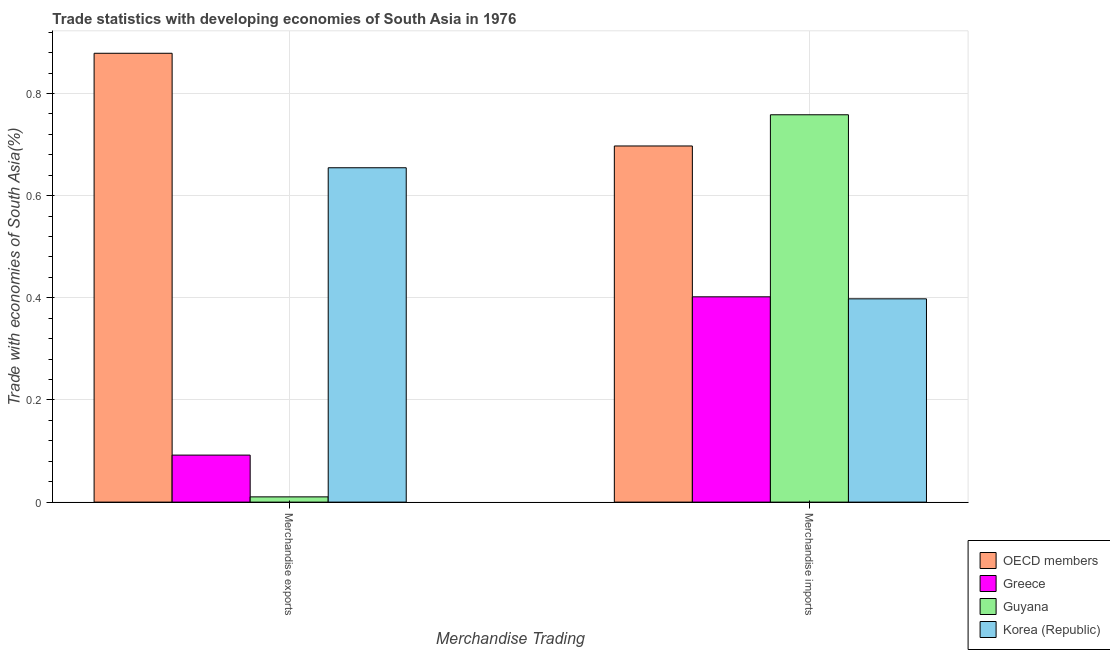How many different coloured bars are there?
Give a very brief answer. 4. Are the number of bars per tick equal to the number of legend labels?
Keep it short and to the point. Yes. Are the number of bars on each tick of the X-axis equal?
Offer a terse response. Yes. How many bars are there on the 1st tick from the left?
Your answer should be very brief. 4. What is the label of the 1st group of bars from the left?
Provide a succinct answer. Merchandise exports. What is the merchandise imports in Greece?
Your response must be concise. 0.4. Across all countries, what is the maximum merchandise exports?
Give a very brief answer. 0.88. Across all countries, what is the minimum merchandise imports?
Offer a terse response. 0.4. In which country was the merchandise imports maximum?
Make the answer very short. Guyana. In which country was the merchandise imports minimum?
Provide a succinct answer. Korea (Republic). What is the total merchandise imports in the graph?
Your response must be concise. 2.26. What is the difference between the merchandise imports in Korea (Republic) and that in Greece?
Your answer should be very brief. -0. What is the difference between the merchandise imports in Guyana and the merchandise exports in OECD members?
Your response must be concise. -0.12. What is the average merchandise imports per country?
Make the answer very short. 0.56. What is the difference between the merchandise exports and merchandise imports in Guyana?
Make the answer very short. -0.75. In how many countries, is the merchandise exports greater than 0.52 %?
Make the answer very short. 2. What is the ratio of the merchandise exports in OECD members to that in Greece?
Your answer should be compact. 9.55. Is the merchandise exports in Greece less than that in Guyana?
Your response must be concise. No. In how many countries, is the merchandise imports greater than the average merchandise imports taken over all countries?
Offer a very short reply. 2. What does the 3rd bar from the left in Merchandise exports represents?
Your answer should be compact. Guyana. Are all the bars in the graph horizontal?
Provide a short and direct response. No. Are the values on the major ticks of Y-axis written in scientific E-notation?
Offer a terse response. No. What is the title of the graph?
Your response must be concise. Trade statistics with developing economies of South Asia in 1976. What is the label or title of the X-axis?
Offer a very short reply. Merchandise Trading. What is the label or title of the Y-axis?
Your answer should be very brief. Trade with economies of South Asia(%). What is the Trade with economies of South Asia(%) of OECD members in Merchandise exports?
Give a very brief answer. 0.88. What is the Trade with economies of South Asia(%) in Greece in Merchandise exports?
Keep it short and to the point. 0.09. What is the Trade with economies of South Asia(%) of Guyana in Merchandise exports?
Your response must be concise. 0.01. What is the Trade with economies of South Asia(%) in Korea (Republic) in Merchandise exports?
Make the answer very short. 0.65. What is the Trade with economies of South Asia(%) in OECD members in Merchandise imports?
Offer a very short reply. 0.7. What is the Trade with economies of South Asia(%) of Greece in Merchandise imports?
Offer a terse response. 0.4. What is the Trade with economies of South Asia(%) of Guyana in Merchandise imports?
Your response must be concise. 0.76. What is the Trade with economies of South Asia(%) in Korea (Republic) in Merchandise imports?
Offer a very short reply. 0.4. Across all Merchandise Trading, what is the maximum Trade with economies of South Asia(%) in OECD members?
Offer a terse response. 0.88. Across all Merchandise Trading, what is the maximum Trade with economies of South Asia(%) in Greece?
Your response must be concise. 0.4. Across all Merchandise Trading, what is the maximum Trade with economies of South Asia(%) in Guyana?
Your response must be concise. 0.76. Across all Merchandise Trading, what is the maximum Trade with economies of South Asia(%) of Korea (Republic)?
Offer a very short reply. 0.65. Across all Merchandise Trading, what is the minimum Trade with economies of South Asia(%) in OECD members?
Offer a very short reply. 0.7. Across all Merchandise Trading, what is the minimum Trade with economies of South Asia(%) in Greece?
Your answer should be compact. 0.09. Across all Merchandise Trading, what is the minimum Trade with economies of South Asia(%) of Guyana?
Keep it short and to the point. 0.01. Across all Merchandise Trading, what is the minimum Trade with economies of South Asia(%) of Korea (Republic)?
Your answer should be compact. 0.4. What is the total Trade with economies of South Asia(%) of OECD members in the graph?
Keep it short and to the point. 1.58. What is the total Trade with economies of South Asia(%) in Greece in the graph?
Provide a short and direct response. 0.49. What is the total Trade with economies of South Asia(%) of Guyana in the graph?
Keep it short and to the point. 0.77. What is the total Trade with economies of South Asia(%) of Korea (Republic) in the graph?
Provide a succinct answer. 1.05. What is the difference between the Trade with economies of South Asia(%) in OECD members in Merchandise exports and that in Merchandise imports?
Ensure brevity in your answer.  0.18. What is the difference between the Trade with economies of South Asia(%) of Greece in Merchandise exports and that in Merchandise imports?
Your response must be concise. -0.31. What is the difference between the Trade with economies of South Asia(%) of Guyana in Merchandise exports and that in Merchandise imports?
Offer a terse response. -0.75. What is the difference between the Trade with economies of South Asia(%) of Korea (Republic) in Merchandise exports and that in Merchandise imports?
Give a very brief answer. 0.26. What is the difference between the Trade with economies of South Asia(%) of OECD members in Merchandise exports and the Trade with economies of South Asia(%) of Greece in Merchandise imports?
Offer a very short reply. 0.48. What is the difference between the Trade with economies of South Asia(%) in OECD members in Merchandise exports and the Trade with economies of South Asia(%) in Guyana in Merchandise imports?
Make the answer very short. 0.12. What is the difference between the Trade with economies of South Asia(%) of OECD members in Merchandise exports and the Trade with economies of South Asia(%) of Korea (Republic) in Merchandise imports?
Your response must be concise. 0.48. What is the difference between the Trade with economies of South Asia(%) of Greece in Merchandise exports and the Trade with economies of South Asia(%) of Guyana in Merchandise imports?
Offer a very short reply. -0.67. What is the difference between the Trade with economies of South Asia(%) in Greece in Merchandise exports and the Trade with economies of South Asia(%) in Korea (Republic) in Merchandise imports?
Your answer should be very brief. -0.31. What is the difference between the Trade with economies of South Asia(%) of Guyana in Merchandise exports and the Trade with economies of South Asia(%) of Korea (Republic) in Merchandise imports?
Ensure brevity in your answer.  -0.39. What is the average Trade with economies of South Asia(%) in OECD members per Merchandise Trading?
Give a very brief answer. 0.79. What is the average Trade with economies of South Asia(%) of Greece per Merchandise Trading?
Provide a succinct answer. 0.25. What is the average Trade with economies of South Asia(%) of Guyana per Merchandise Trading?
Give a very brief answer. 0.38. What is the average Trade with economies of South Asia(%) of Korea (Republic) per Merchandise Trading?
Provide a short and direct response. 0.53. What is the difference between the Trade with economies of South Asia(%) of OECD members and Trade with economies of South Asia(%) of Greece in Merchandise exports?
Provide a short and direct response. 0.79. What is the difference between the Trade with economies of South Asia(%) in OECD members and Trade with economies of South Asia(%) in Guyana in Merchandise exports?
Make the answer very short. 0.87. What is the difference between the Trade with economies of South Asia(%) in OECD members and Trade with economies of South Asia(%) in Korea (Republic) in Merchandise exports?
Give a very brief answer. 0.22. What is the difference between the Trade with economies of South Asia(%) in Greece and Trade with economies of South Asia(%) in Guyana in Merchandise exports?
Offer a terse response. 0.08. What is the difference between the Trade with economies of South Asia(%) in Greece and Trade with economies of South Asia(%) in Korea (Republic) in Merchandise exports?
Keep it short and to the point. -0.56. What is the difference between the Trade with economies of South Asia(%) in Guyana and Trade with economies of South Asia(%) in Korea (Republic) in Merchandise exports?
Your answer should be compact. -0.64. What is the difference between the Trade with economies of South Asia(%) in OECD members and Trade with economies of South Asia(%) in Greece in Merchandise imports?
Your answer should be compact. 0.3. What is the difference between the Trade with economies of South Asia(%) of OECD members and Trade with economies of South Asia(%) of Guyana in Merchandise imports?
Your answer should be compact. -0.06. What is the difference between the Trade with economies of South Asia(%) of OECD members and Trade with economies of South Asia(%) of Korea (Republic) in Merchandise imports?
Ensure brevity in your answer.  0.3. What is the difference between the Trade with economies of South Asia(%) in Greece and Trade with economies of South Asia(%) in Guyana in Merchandise imports?
Give a very brief answer. -0.36. What is the difference between the Trade with economies of South Asia(%) of Greece and Trade with economies of South Asia(%) of Korea (Republic) in Merchandise imports?
Offer a terse response. 0. What is the difference between the Trade with economies of South Asia(%) in Guyana and Trade with economies of South Asia(%) in Korea (Republic) in Merchandise imports?
Your response must be concise. 0.36. What is the ratio of the Trade with economies of South Asia(%) in OECD members in Merchandise exports to that in Merchandise imports?
Your response must be concise. 1.26. What is the ratio of the Trade with economies of South Asia(%) of Greece in Merchandise exports to that in Merchandise imports?
Your response must be concise. 0.23. What is the ratio of the Trade with economies of South Asia(%) in Guyana in Merchandise exports to that in Merchandise imports?
Your answer should be compact. 0.01. What is the ratio of the Trade with economies of South Asia(%) in Korea (Republic) in Merchandise exports to that in Merchandise imports?
Keep it short and to the point. 1.64. What is the difference between the highest and the second highest Trade with economies of South Asia(%) in OECD members?
Make the answer very short. 0.18. What is the difference between the highest and the second highest Trade with economies of South Asia(%) in Greece?
Provide a succinct answer. 0.31. What is the difference between the highest and the second highest Trade with economies of South Asia(%) of Guyana?
Provide a succinct answer. 0.75. What is the difference between the highest and the second highest Trade with economies of South Asia(%) of Korea (Republic)?
Your answer should be compact. 0.26. What is the difference between the highest and the lowest Trade with economies of South Asia(%) of OECD members?
Give a very brief answer. 0.18. What is the difference between the highest and the lowest Trade with economies of South Asia(%) in Greece?
Provide a succinct answer. 0.31. What is the difference between the highest and the lowest Trade with economies of South Asia(%) in Guyana?
Offer a very short reply. 0.75. What is the difference between the highest and the lowest Trade with economies of South Asia(%) of Korea (Republic)?
Your response must be concise. 0.26. 